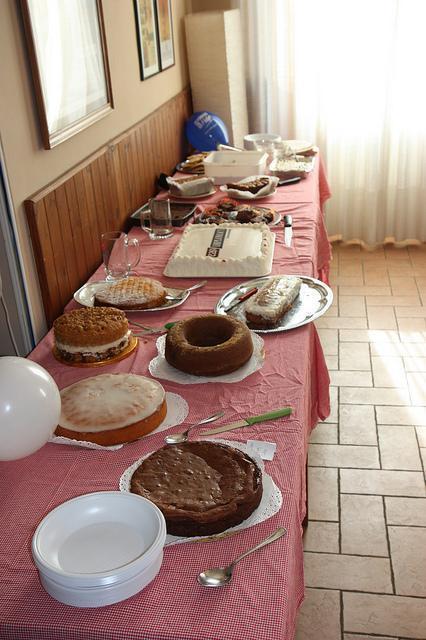How many cakes needed to cool down before adding a creamy glaze to it?
Choose the correct response, then elucidate: 'Answer: answer
Rationale: rationale.'
Options: Two, none, three, one. Answer: three.
Rationale: There are six cakes total and half of them have cream on top. 